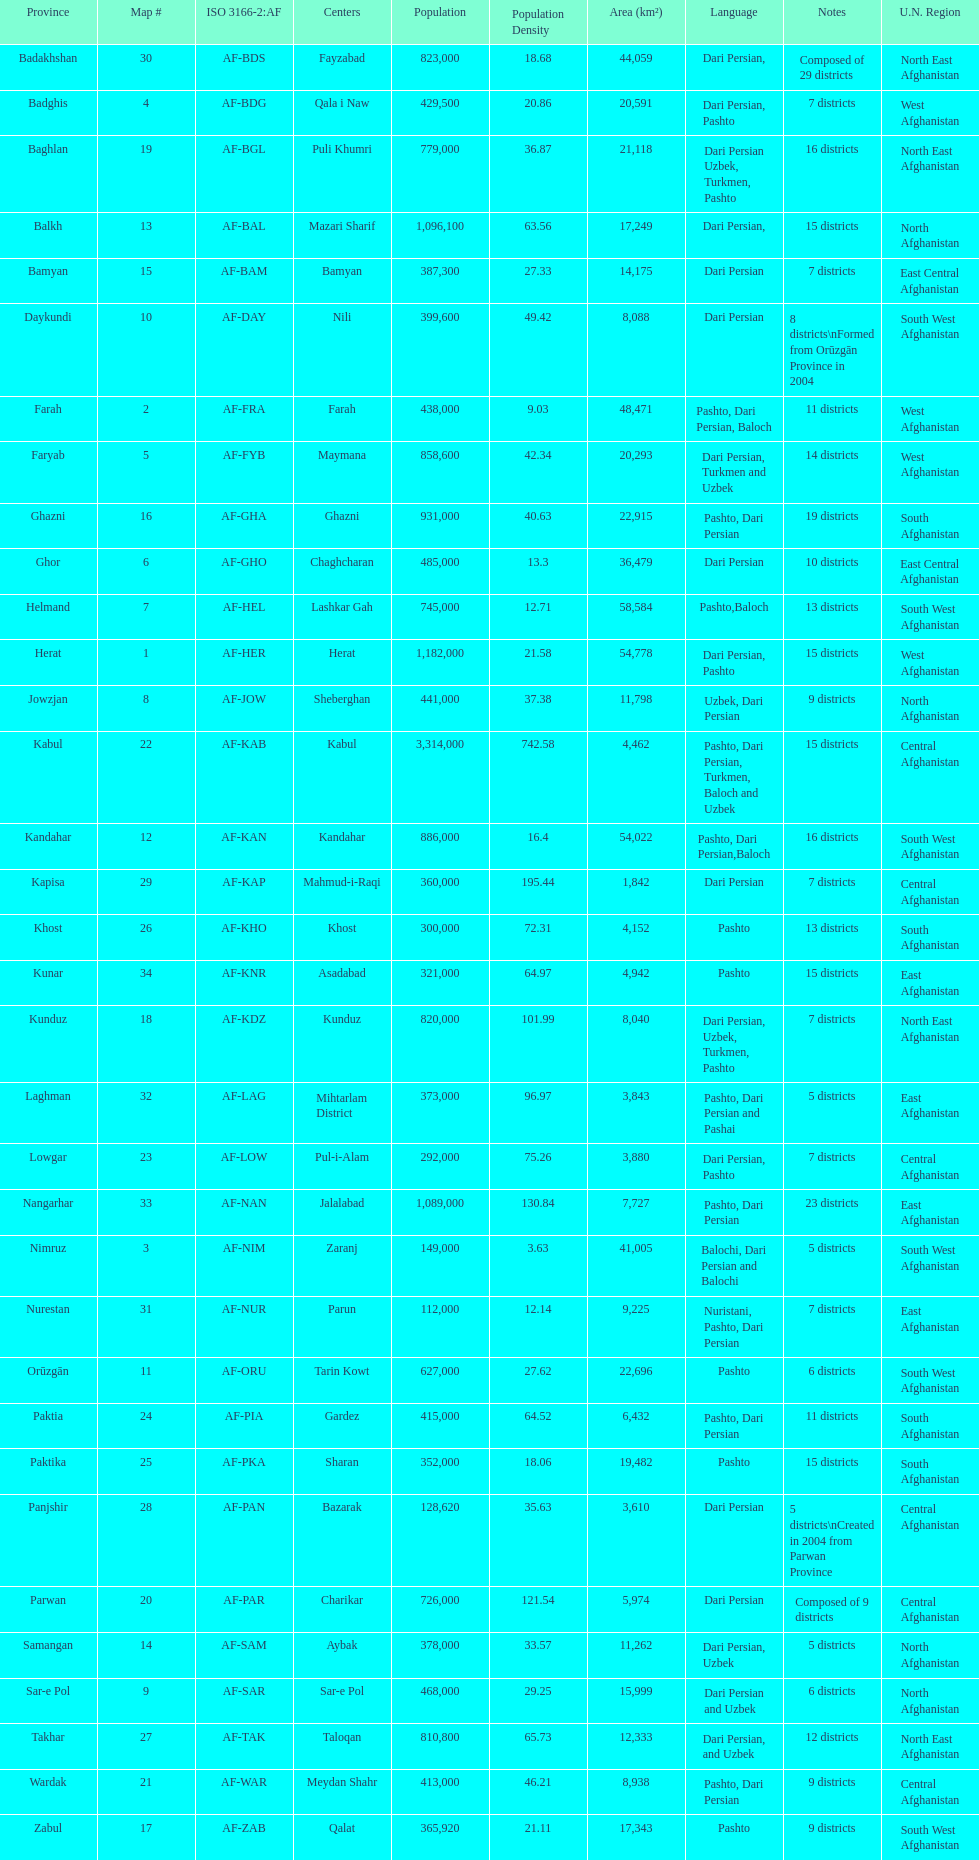Can you give me this table as a dict? {'header': ['Province', 'Map #', 'ISO 3166-2:AF', 'Centers', 'Population', 'Population Density', 'Area (km²)', 'Language', 'Notes', 'U.N. Region'], 'rows': [['Badakhshan', '30', 'AF-BDS', 'Fayzabad', '823,000', '18.68', '44,059', 'Dari Persian,', 'Composed of 29 districts', 'North East Afghanistan'], ['Badghis', '4', 'AF-BDG', 'Qala i Naw', '429,500', '20.86', '20,591', 'Dari Persian, Pashto', '7 districts', 'West Afghanistan'], ['Baghlan', '19', 'AF-BGL', 'Puli Khumri', '779,000', '36.87', '21,118', 'Dari Persian Uzbek, Turkmen, Pashto', '16 districts', 'North East Afghanistan'], ['Balkh', '13', 'AF-BAL', 'Mazari Sharif', '1,096,100', '63.56', '17,249', 'Dari Persian,', '15 districts', 'North Afghanistan'], ['Bamyan', '15', 'AF-BAM', 'Bamyan', '387,300', '27.33', '14,175', 'Dari Persian', '7 districts', 'East Central Afghanistan'], ['Daykundi', '10', 'AF-DAY', 'Nili', '399,600', '49.42', '8,088', 'Dari Persian', '8 districts\\nFormed from Orūzgān Province in 2004', 'South West Afghanistan'], ['Farah', '2', 'AF-FRA', 'Farah', '438,000', '9.03', '48,471', 'Pashto, Dari Persian, Baloch', '11 districts', 'West Afghanistan'], ['Faryab', '5', 'AF-FYB', 'Maymana', '858,600', '42.34', '20,293', 'Dari Persian, Turkmen and Uzbek', '14 districts', 'West Afghanistan'], ['Ghazni', '16', 'AF-GHA', 'Ghazni', '931,000', '40.63', '22,915', 'Pashto, Dari Persian', '19 districts', 'South Afghanistan'], ['Ghor', '6', 'AF-GHO', 'Chaghcharan', '485,000', '13.3', '36,479', 'Dari Persian', '10 districts', 'East Central Afghanistan'], ['Helmand', '7', 'AF-HEL', 'Lashkar Gah', '745,000', '12.71', '58,584', 'Pashto,Baloch', '13 districts', 'South West Afghanistan'], ['Herat', '1', 'AF-HER', 'Herat', '1,182,000', '21.58', '54,778', 'Dari Persian, Pashto', '15 districts', 'West Afghanistan'], ['Jowzjan', '8', 'AF-JOW', 'Sheberghan', '441,000', '37.38', '11,798', 'Uzbek, Dari Persian', '9 districts', 'North Afghanistan'], ['Kabul', '22', 'AF-KAB', 'Kabul', '3,314,000', '742.58', '4,462', 'Pashto, Dari Persian, Turkmen, Baloch and Uzbek', '15 districts', 'Central Afghanistan'], ['Kandahar', '12', 'AF-KAN', 'Kandahar', '886,000', '16.4', '54,022', 'Pashto, Dari Persian,Baloch', '16 districts', 'South West Afghanistan'], ['Kapisa', '29', 'AF-KAP', 'Mahmud-i-Raqi', '360,000', '195.44', '1,842', 'Dari Persian', '7 districts', 'Central Afghanistan'], ['Khost', '26', 'AF-KHO', 'Khost', '300,000', '72.31', '4,152', 'Pashto', '13 districts', 'South Afghanistan'], ['Kunar', '34', 'AF-KNR', 'Asadabad', '321,000', '64.97', '4,942', 'Pashto', '15 districts', 'East Afghanistan'], ['Kunduz', '18', 'AF-KDZ', 'Kunduz', '820,000', '101.99', '8,040', 'Dari Persian, Uzbek, Turkmen, Pashto', '7 districts', 'North East Afghanistan'], ['Laghman', '32', 'AF-LAG', 'Mihtarlam District', '373,000', '96.97', '3,843', 'Pashto, Dari Persian and Pashai', '5 districts', 'East Afghanistan'], ['Lowgar', '23', 'AF-LOW', 'Pul-i-Alam', '292,000', '75.26', '3,880', 'Dari Persian, Pashto', '7 districts', 'Central Afghanistan'], ['Nangarhar', '33', 'AF-NAN', 'Jalalabad', '1,089,000', '130.84', '7,727', 'Pashto, Dari Persian', '23 districts', 'East Afghanistan'], ['Nimruz', '3', 'AF-NIM', 'Zaranj', '149,000', '3.63', '41,005', 'Balochi, Dari Persian and Balochi', '5 districts', 'South West Afghanistan'], ['Nurestan', '31', 'AF-NUR', 'Parun', '112,000', '12.14', '9,225', 'Nuristani, Pashto, Dari Persian', '7 districts', 'East Afghanistan'], ['Orūzgān', '11', 'AF-ORU', 'Tarin Kowt', '627,000', '27.62', '22,696', 'Pashto', '6 districts', 'South West Afghanistan'], ['Paktia', '24', 'AF-PIA', 'Gardez', '415,000', '64.52', '6,432', 'Pashto, Dari Persian', '11 districts', 'South Afghanistan'], ['Paktika', '25', 'AF-PKA', 'Sharan', '352,000', '18.06', '19,482', 'Pashto', '15 districts', 'South Afghanistan'], ['Panjshir', '28', 'AF-PAN', 'Bazarak', '128,620', '35.63', '3,610', 'Dari Persian', '5 districts\\nCreated in 2004 from Parwan Province', 'Central Afghanistan'], ['Parwan', '20', 'AF-PAR', 'Charikar', '726,000', '121.54', '5,974', 'Dari Persian', 'Composed of 9 districts', 'Central Afghanistan'], ['Samangan', '14', 'AF-SAM', 'Aybak', '378,000', '33.57', '11,262', 'Dari Persian, Uzbek', '5 districts', 'North Afghanistan'], ['Sar-e Pol', '9', 'AF-SAR', 'Sar-e Pol', '468,000', '29.25', '15,999', 'Dari Persian and Uzbek', '6 districts', 'North Afghanistan'], ['Takhar', '27', 'AF-TAK', 'Taloqan', '810,800', '65.73', '12,333', 'Dari Persian, and Uzbek', '12 districts', 'North East Afghanistan'], ['Wardak', '21', 'AF-WAR', 'Meydan Shahr', '413,000', '46.21', '8,938', 'Pashto, Dari Persian', '9 districts', 'Central Afghanistan'], ['Zabul', '17', 'AF-ZAB', 'Qalat', '365,920', '21.11', '17,343', 'Pashto', '9 districts', 'South West Afghanistan']]} Which province has the most districts? Badakhshan. 